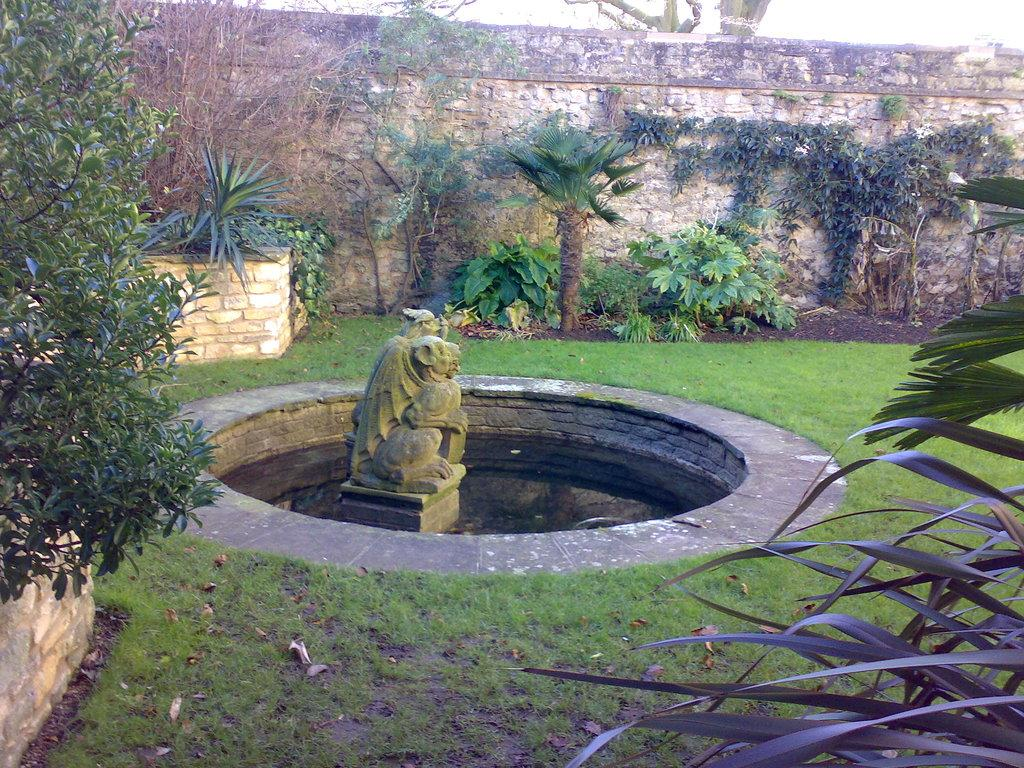What is the main subject of the image? There is a sculpture in the image. What can be seen in the background of the image? Water, grass, and a wall are visible in the image. Are there any plants in the image? Yes, there are plants in the image. Can you see any pigs or rabbits in the office setting in the image? There is no office setting or pigs or rabbits present in the image. 